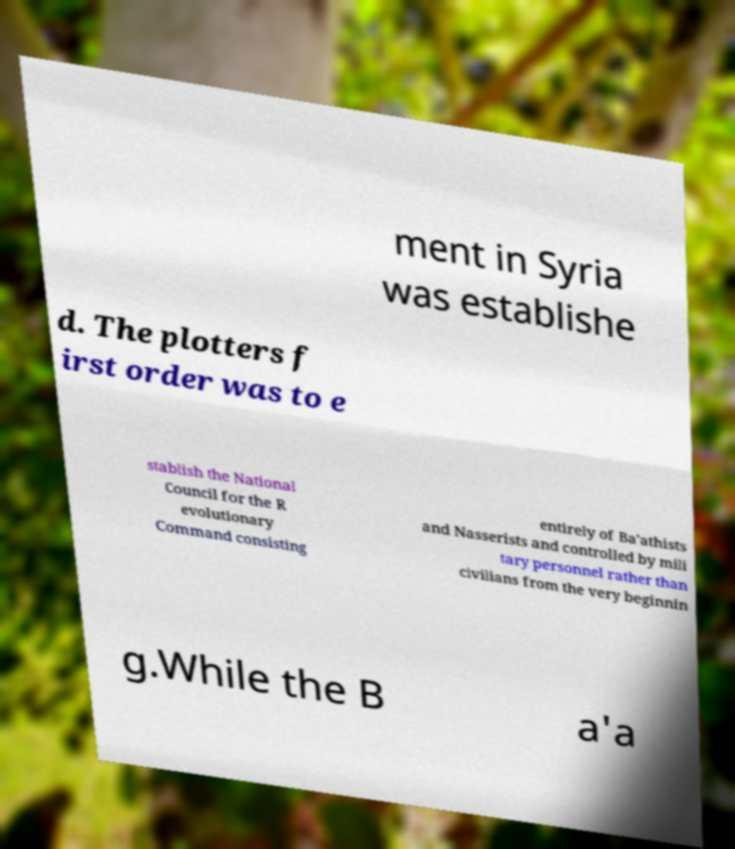There's text embedded in this image that I need extracted. Can you transcribe it verbatim? ment in Syria was establishe d. The plotters f irst order was to e stablish the National Council for the R evolutionary Command consisting entirely of Ba'athists and Nasserists and controlled by mili tary personnel rather than civilians from the very beginnin g.While the B a'a 